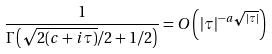<formula> <loc_0><loc_0><loc_500><loc_500>\frac { 1 } { \Gamma \left ( \sqrt { 2 ( c + i \tau ) } / 2 + 1 / 2 \right ) } = O \left ( | \tau | ^ { - a \sqrt { | \tau | } } \right )</formula> 